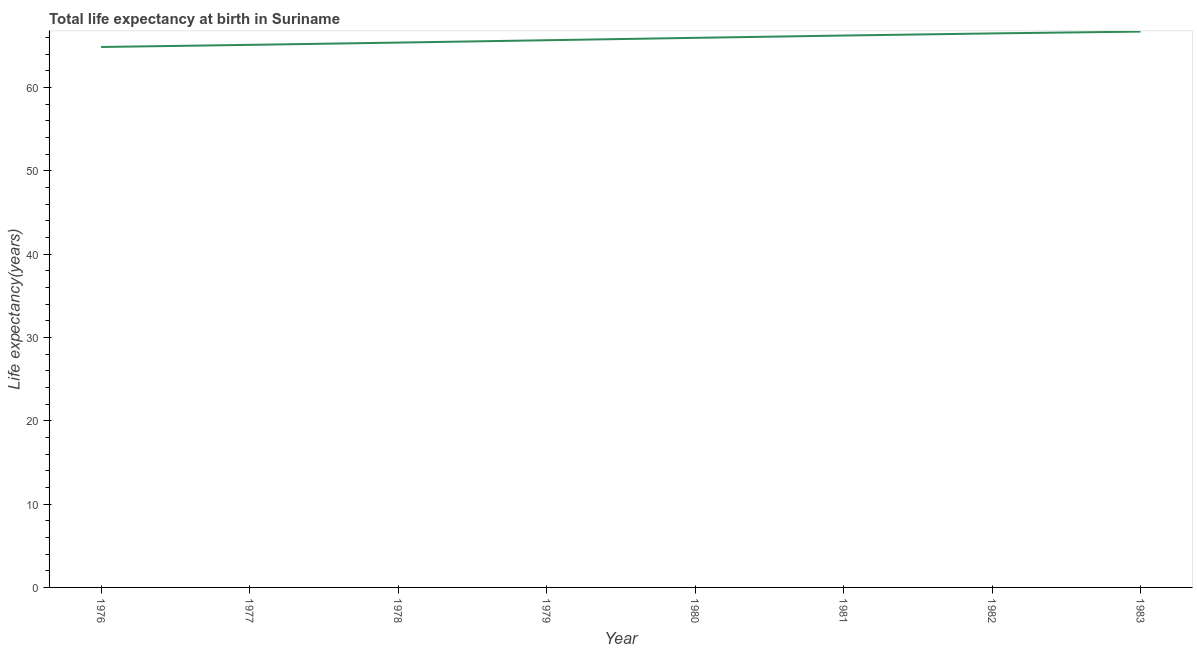What is the life expectancy at birth in 1982?
Provide a short and direct response. 66.47. Across all years, what is the maximum life expectancy at birth?
Your answer should be compact. 66.69. Across all years, what is the minimum life expectancy at birth?
Provide a succinct answer. 64.84. In which year was the life expectancy at birth maximum?
Your answer should be compact. 1983. In which year was the life expectancy at birth minimum?
Ensure brevity in your answer.  1976. What is the sum of the life expectancy at birth?
Give a very brief answer. 526.28. What is the difference between the life expectancy at birth in 1977 and 1980?
Ensure brevity in your answer.  -0.84. What is the average life expectancy at birth per year?
Your answer should be very brief. 65.79. What is the median life expectancy at birth?
Keep it short and to the point. 65.8. In how many years, is the life expectancy at birth greater than 22 years?
Your answer should be compact. 8. What is the ratio of the life expectancy at birth in 1976 to that in 1977?
Your answer should be compact. 1. Is the difference between the life expectancy at birth in 1976 and 1978 greater than the difference between any two years?
Your response must be concise. No. What is the difference between the highest and the second highest life expectancy at birth?
Give a very brief answer. 0.22. What is the difference between the highest and the lowest life expectancy at birth?
Keep it short and to the point. 1.85. Does the life expectancy at birth monotonically increase over the years?
Your response must be concise. Yes. How many years are there in the graph?
Give a very brief answer. 8. What is the difference between two consecutive major ticks on the Y-axis?
Your answer should be very brief. 10. Are the values on the major ticks of Y-axis written in scientific E-notation?
Give a very brief answer. No. Does the graph contain any zero values?
Your response must be concise. No. Does the graph contain grids?
Your answer should be compact. No. What is the title of the graph?
Offer a very short reply. Total life expectancy at birth in Suriname. What is the label or title of the X-axis?
Offer a terse response. Year. What is the label or title of the Y-axis?
Your answer should be compact. Life expectancy(years). What is the Life expectancy(years) in 1976?
Offer a terse response. 64.84. What is the Life expectancy(years) in 1977?
Your response must be concise. 65.1. What is the Life expectancy(years) of 1978?
Your answer should be very brief. 65.37. What is the Life expectancy(years) of 1979?
Offer a very short reply. 65.65. What is the Life expectancy(years) of 1980?
Offer a very short reply. 65.94. What is the Life expectancy(years) of 1981?
Your response must be concise. 66.22. What is the Life expectancy(years) of 1982?
Keep it short and to the point. 66.47. What is the Life expectancy(years) of 1983?
Provide a succinct answer. 66.69. What is the difference between the Life expectancy(years) in 1976 and 1977?
Your answer should be compact. -0.26. What is the difference between the Life expectancy(years) in 1976 and 1978?
Make the answer very short. -0.53. What is the difference between the Life expectancy(years) in 1976 and 1979?
Offer a very short reply. -0.81. What is the difference between the Life expectancy(years) in 1976 and 1980?
Your answer should be compact. -1.1. What is the difference between the Life expectancy(years) in 1976 and 1981?
Provide a succinct answer. -1.37. What is the difference between the Life expectancy(years) in 1976 and 1982?
Offer a very short reply. -1.63. What is the difference between the Life expectancy(years) in 1976 and 1983?
Make the answer very short. -1.85. What is the difference between the Life expectancy(years) in 1977 and 1978?
Ensure brevity in your answer.  -0.27. What is the difference between the Life expectancy(years) in 1977 and 1979?
Ensure brevity in your answer.  -0.55. What is the difference between the Life expectancy(years) in 1977 and 1980?
Your answer should be very brief. -0.84. What is the difference between the Life expectancy(years) in 1977 and 1981?
Make the answer very short. -1.12. What is the difference between the Life expectancy(years) in 1977 and 1982?
Offer a terse response. -1.37. What is the difference between the Life expectancy(years) in 1977 and 1983?
Keep it short and to the point. -1.59. What is the difference between the Life expectancy(years) in 1978 and 1979?
Keep it short and to the point. -0.28. What is the difference between the Life expectancy(years) in 1978 and 1980?
Ensure brevity in your answer.  -0.57. What is the difference between the Life expectancy(years) in 1978 and 1981?
Ensure brevity in your answer.  -0.85. What is the difference between the Life expectancy(years) in 1978 and 1982?
Your response must be concise. -1.1. What is the difference between the Life expectancy(years) in 1978 and 1983?
Keep it short and to the point. -1.32. What is the difference between the Life expectancy(years) in 1979 and 1980?
Offer a very short reply. -0.29. What is the difference between the Life expectancy(years) in 1979 and 1981?
Your answer should be compact. -0.56. What is the difference between the Life expectancy(years) in 1979 and 1982?
Your response must be concise. -0.82. What is the difference between the Life expectancy(years) in 1979 and 1983?
Ensure brevity in your answer.  -1.04. What is the difference between the Life expectancy(years) in 1980 and 1981?
Keep it short and to the point. -0.28. What is the difference between the Life expectancy(years) in 1980 and 1982?
Provide a succinct answer. -0.53. What is the difference between the Life expectancy(years) in 1980 and 1983?
Make the answer very short. -0.75. What is the difference between the Life expectancy(years) in 1981 and 1982?
Make the answer very short. -0.25. What is the difference between the Life expectancy(years) in 1981 and 1983?
Ensure brevity in your answer.  -0.47. What is the difference between the Life expectancy(years) in 1982 and 1983?
Give a very brief answer. -0.22. What is the ratio of the Life expectancy(years) in 1976 to that in 1977?
Keep it short and to the point. 1. What is the ratio of the Life expectancy(years) in 1976 to that in 1980?
Provide a succinct answer. 0.98. What is the ratio of the Life expectancy(years) in 1976 to that in 1982?
Give a very brief answer. 0.98. What is the ratio of the Life expectancy(years) in 1977 to that in 1979?
Give a very brief answer. 0.99. What is the ratio of the Life expectancy(years) in 1977 to that in 1981?
Offer a very short reply. 0.98. What is the ratio of the Life expectancy(years) in 1977 to that in 1983?
Give a very brief answer. 0.98. What is the ratio of the Life expectancy(years) in 1978 to that in 1979?
Make the answer very short. 1. What is the ratio of the Life expectancy(years) in 1978 to that in 1980?
Your response must be concise. 0.99. What is the ratio of the Life expectancy(years) in 1978 to that in 1983?
Offer a very short reply. 0.98. What is the ratio of the Life expectancy(years) in 1979 to that in 1981?
Make the answer very short. 0.99. What is the ratio of the Life expectancy(years) in 1979 to that in 1982?
Provide a short and direct response. 0.99. What is the ratio of the Life expectancy(years) in 1979 to that in 1983?
Give a very brief answer. 0.98. What is the ratio of the Life expectancy(years) in 1980 to that in 1983?
Your answer should be compact. 0.99. What is the ratio of the Life expectancy(years) in 1981 to that in 1983?
Your response must be concise. 0.99. 